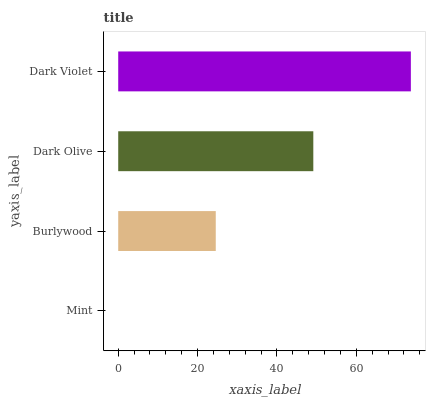Is Mint the minimum?
Answer yes or no. Yes. Is Dark Violet the maximum?
Answer yes or no. Yes. Is Burlywood the minimum?
Answer yes or no. No. Is Burlywood the maximum?
Answer yes or no. No. Is Burlywood greater than Mint?
Answer yes or no. Yes. Is Mint less than Burlywood?
Answer yes or no. Yes. Is Mint greater than Burlywood?
Answer yes or no. No. Is Burlywood less than Mint?
Answer yes or no. No. Is Dark Olive the high median?
Answer yes or no. Yes. Is Burlywood the low median?
Answer yes or no. Yes. Is Burlywood the high median?
Answer yes or no. No. Is Dark Olive the low median?
Answer yes or no. No. 